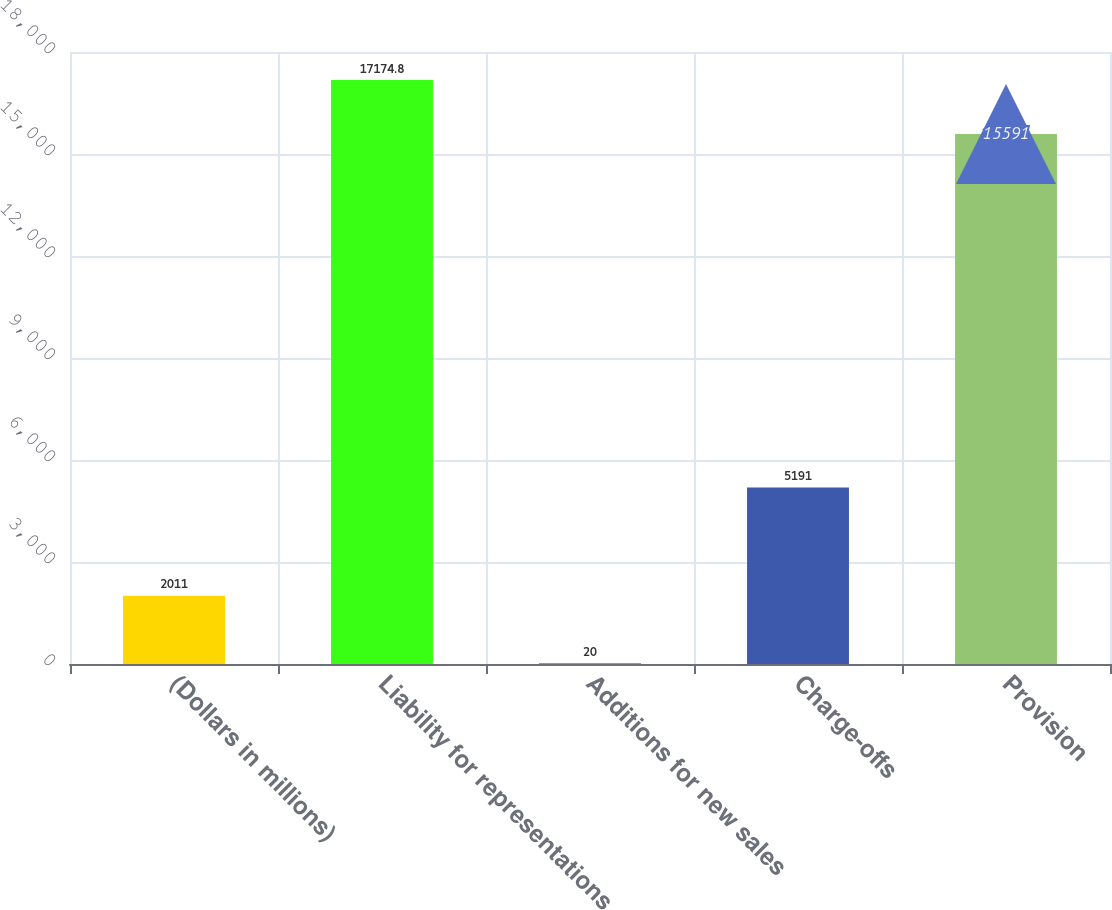Convert chart. <chart><loc_0><loc_0><loc_500><loc_500><bar_chart><fcel>(Dollars in millions)<fcel>Liability for representations<fcel>Additions for new sales<fcel>Charge-offs<fcel>Provision<nl><fcel>2011<fcel>17174.8<fcel>20<fcel>5191<fcel>15591<nl></chart> 